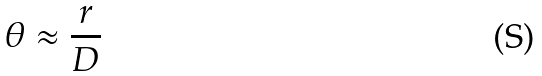<formula> <loc_0><loc_0><loc_500><loc_500>\theta \approx \frac { r } { D }</formula> 